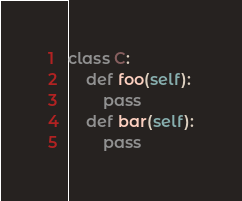<code> <loc_0><loc_0><loc_500><loc_500><_Python_>class C:
    def foo(self):
        pass
    def bar(self):
        pass</code> 